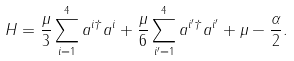<formula> <loc_0><loc_0><loc_500><loc_500>H = \frac { \mu } 3 \sum _ { i = 1 } ^ { 4 } a ^ { i \dagger } a ^ { i } + \frac { \mu } 6 \sum _ { i ^ { \prime } = 1 } ^ { 4 } a ^ { i ^ { \prime } \dagger } a ^ { i ^ { \prime } } + \mu - \frac { \alpha } { 2 } .</formula> 